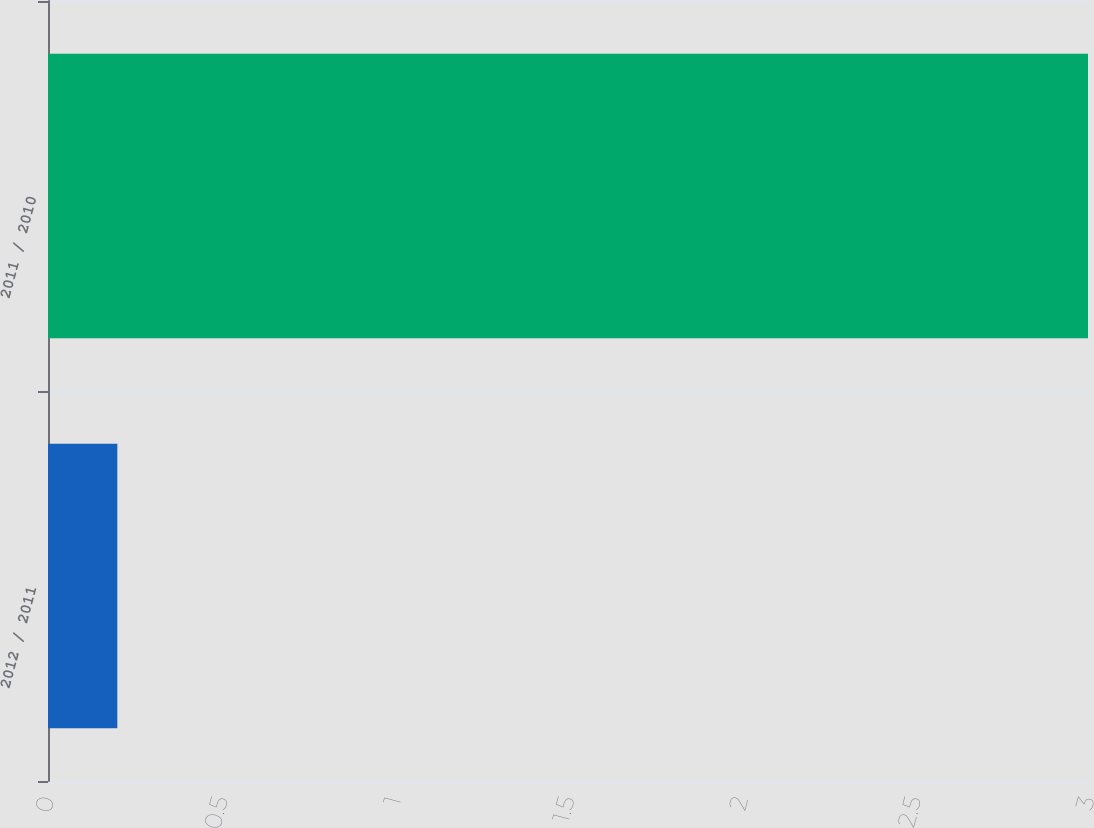Convert chart. <chart><loc_0><loc_0><loc_500><loc_500><bar_chart><fcel>2012 / 2011<fcel>2011 / 2010<nl><fcel>0.2<fcel>3<nl></chart> 